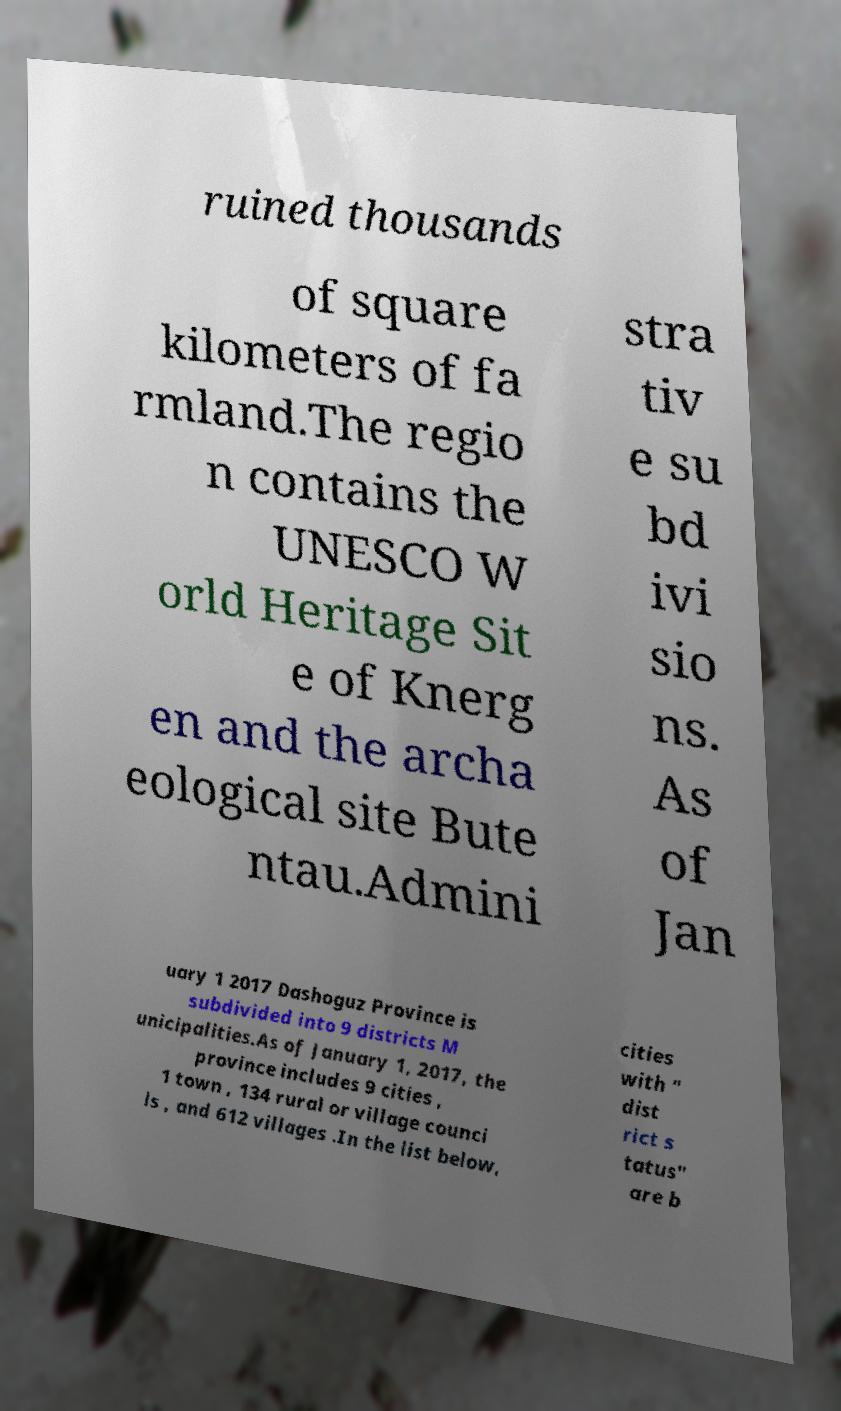Please read and relay the text visible in this image. What does it say? ruined thousands of square kilometers of fa rmland.The regio n contains the UNESCO W orld Heritage Sit e of Knerg en and the archa eological site Bute ntau.Admini stra tiv e su bd ivi sio ns. As of Jan uary 1 2017 Dashoguz Province is subdivided into 9 districts M unicipalities.As of January 1, 2017, the province includes 9 cities , 1 town , 134 rural or village counci ls , and 612 villages .In the list below, cities with " dist rict s tatus" are b 